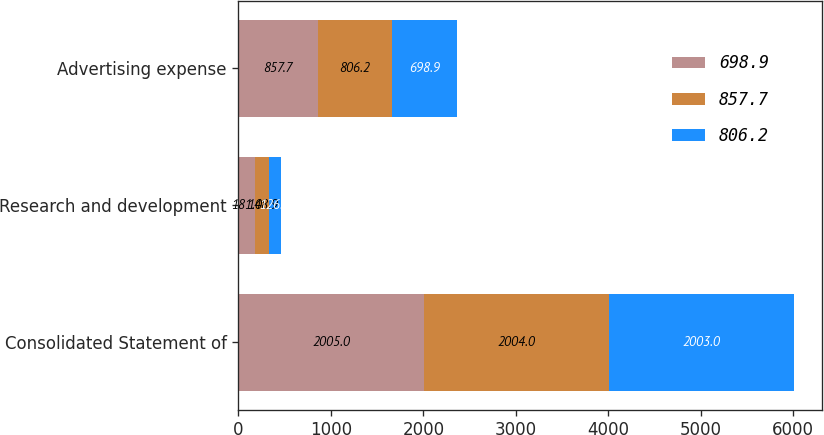Convert chart. <chart><loc_0><loc_0><loc_500><loc_500><stacked_bar_chart><ecel><fcel>Consolidated Statement of<fcel>Research and development<fcel>Advertising expense<nl><fcel>698.9<fcel>2005<fcel>181<fcel>857.7<nl><fcel>857.7<fcel>2004<fcel>148.9<fcel>806.2<nl><fcel>806.2<fcel>2003<fcel>126.7<fcel>698.9<nl></chart> 